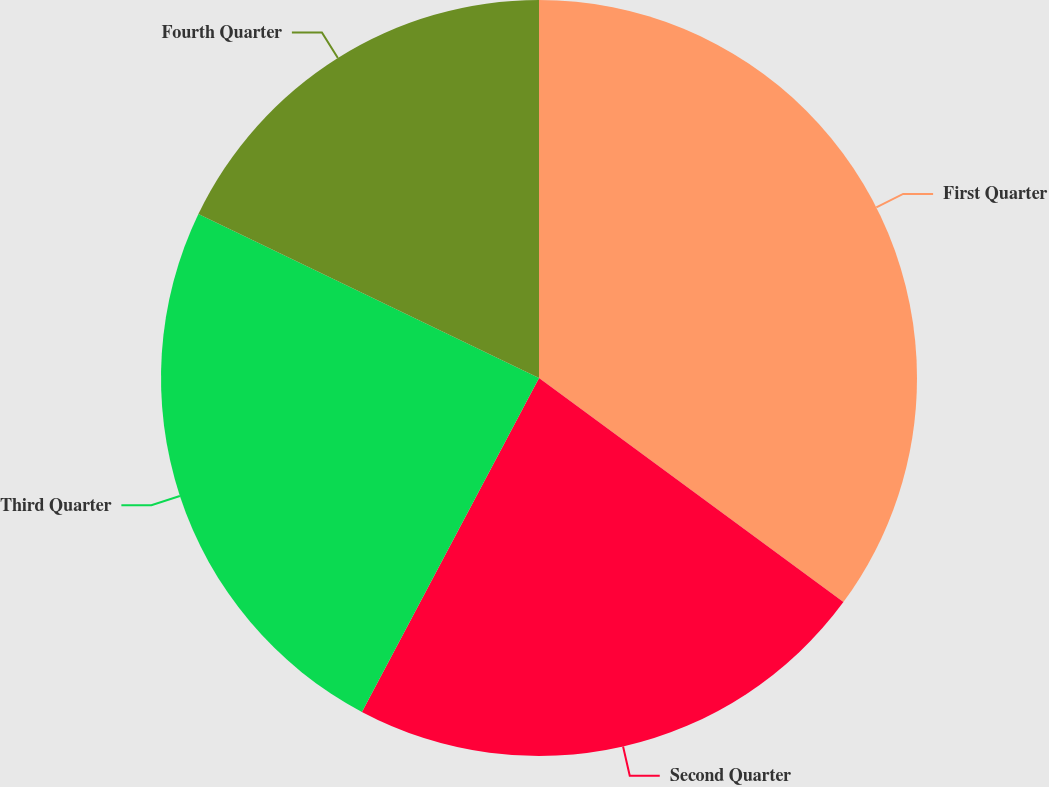Convert chart. <chart><loc_0><loc_0><loc_500><loc_500><pie_chart><fcel>First Quarter<fcel>Second Quarter<fcel>Third Quarter<fcel>Fourth Quarter<nl><fcel>35.1%<fcel>22.66%<fcel>24.38%<fcel>17.86%<nl></chart> 